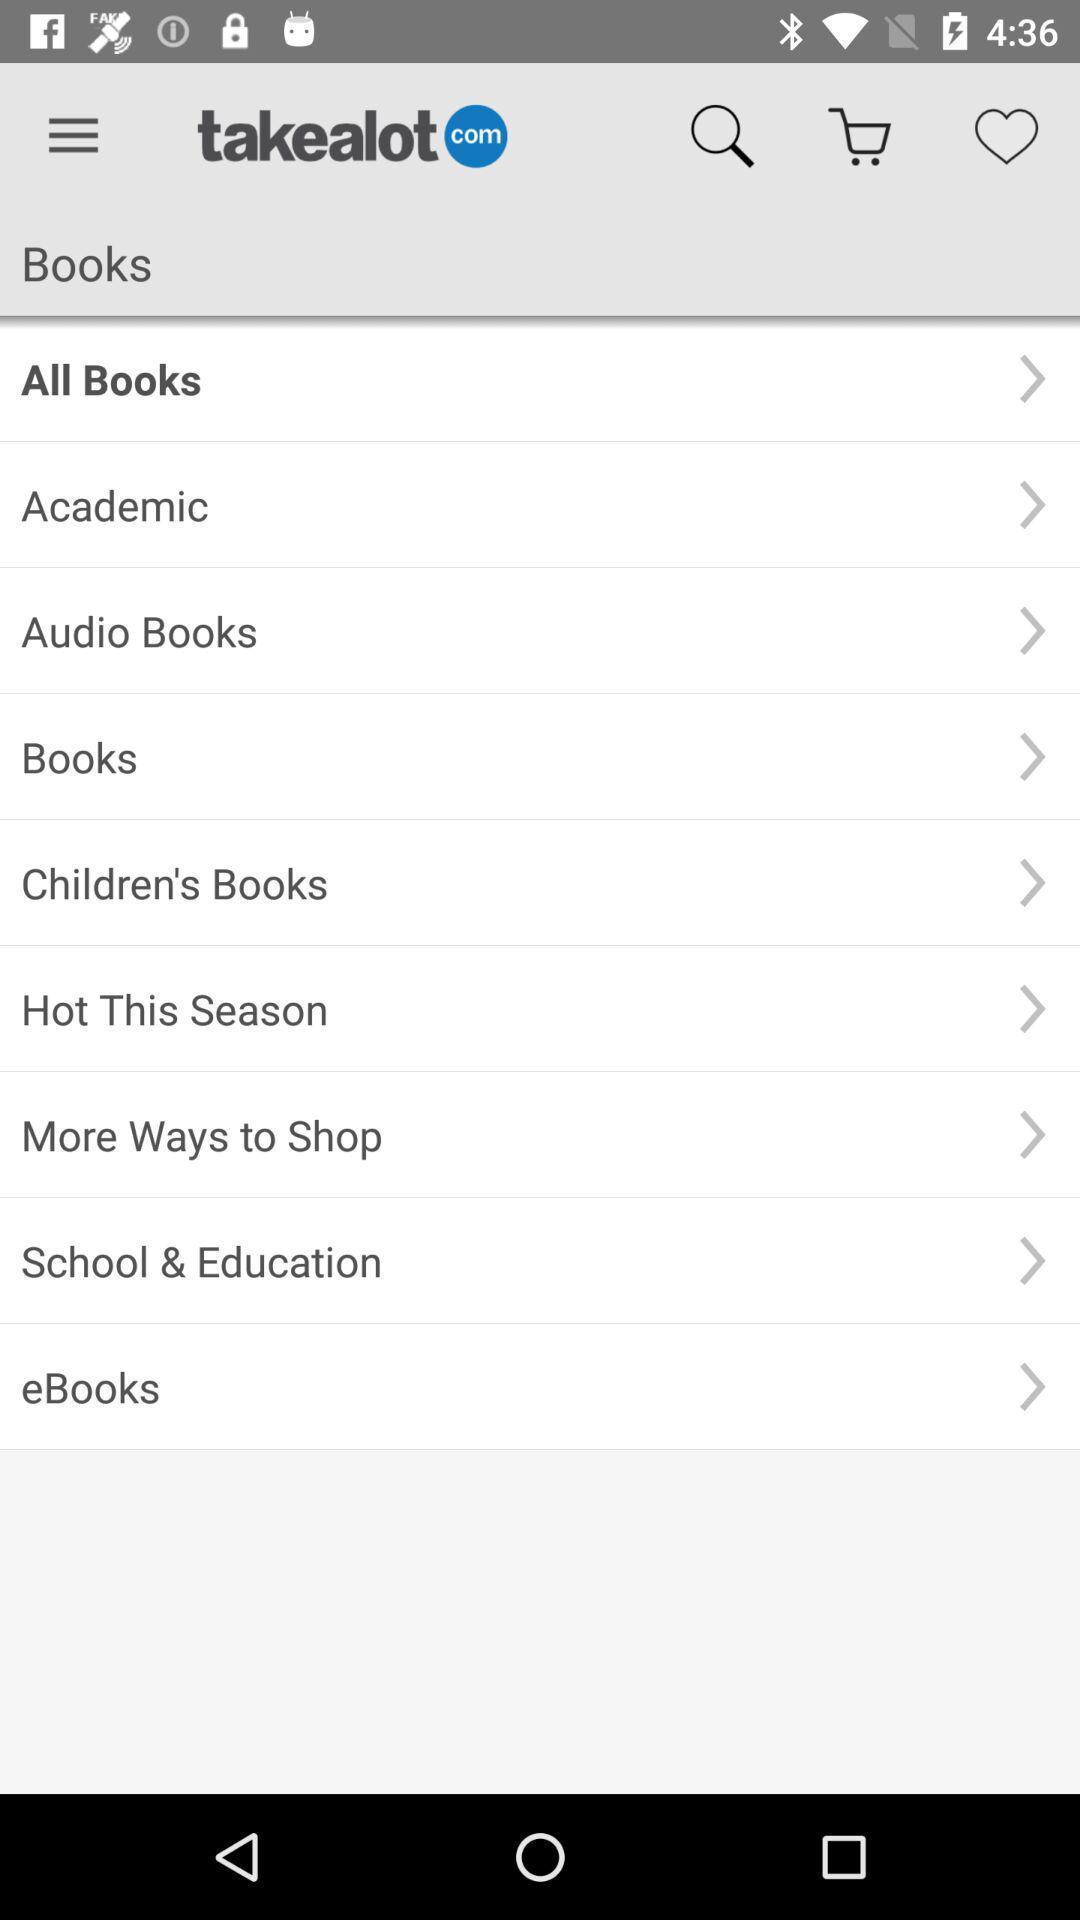Describe the content in this image. Page displaying types of books on shopping app. 